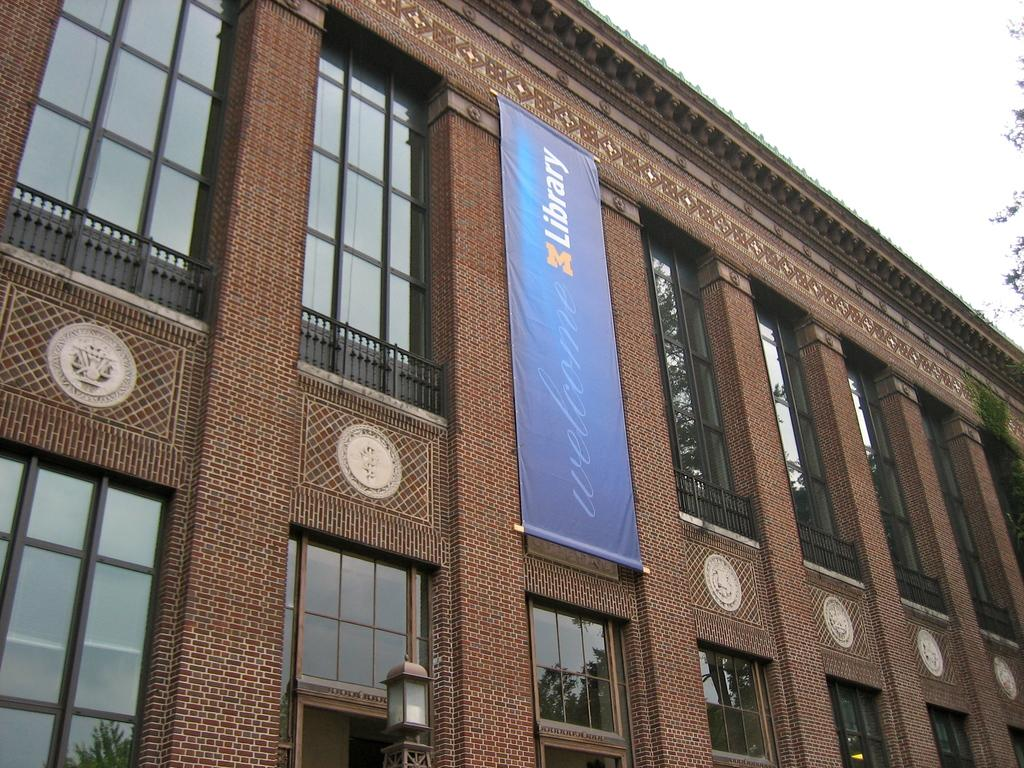<image>
Describe the image concisely. The library is a brick building with a blue banner on it. 